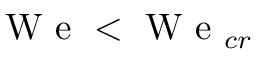<formula> <loc_0><loc_0><loc_500><loc_500>W e < W e _ { c r }</formula> 